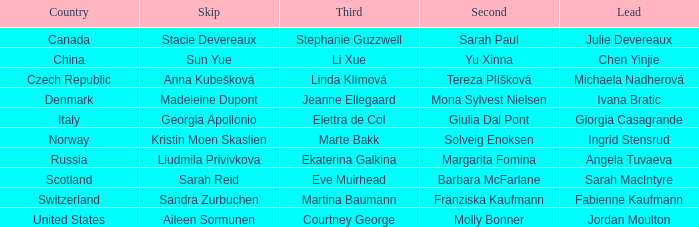What skip has switzerland as the country? Sandra Zurbuchen. 